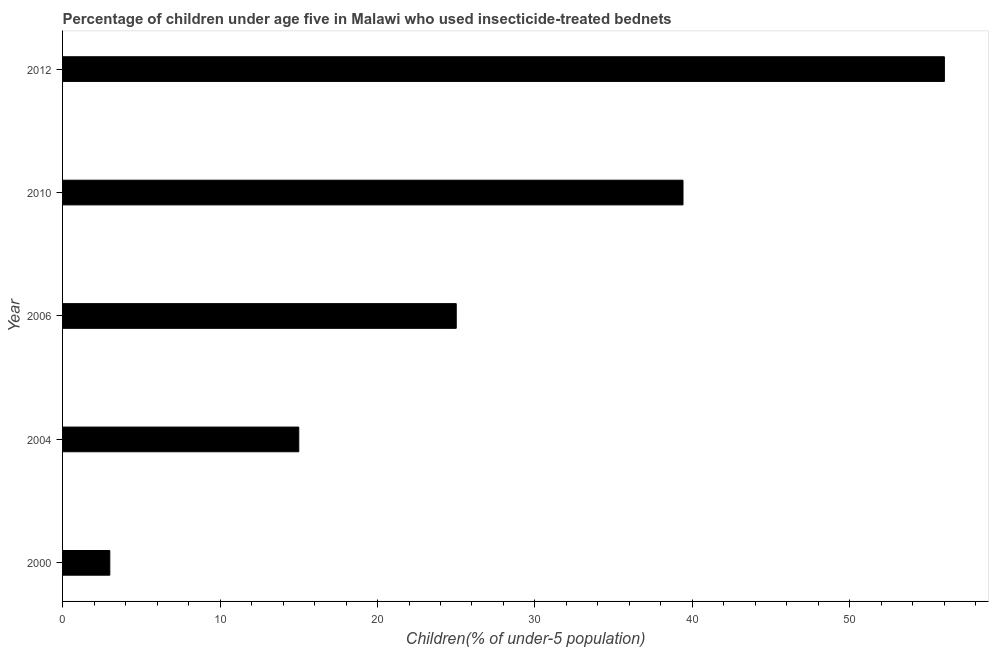Does the graph contain any zero values?
Ensure brevity in your answer.  No. Does the graph contain grids?
Offer a terse response. No. What is the title of the graph?
Make the answer very short. Percentage of children under age five in Malawi who used insecticide-treated bednets. What is the label or title of the X-axis?
Your answer should be very brief. Children(% of under-5 population). Across all years, what is the maximum percentage of children who use of insecticide-treated bed nets?
Give a very brief answer. 56. Across all years, what is the minimum percentage of children who use of insecticide-treated bed nets?
Make the answer very short. 3. In which year was the percentage of children who use of insecticide-treated bed nets maximum?
Your response must be concise. 2012. In which year was the percentage of children who use of insecticide-treated bed nets minimum?
Provide a short and direct response. 2000. What is the sum of the percentage of children who use of insecticide-treated bed nets?
Keep it short and to the point. 138.4. What is the difference between the percentage of children who use of insecticide-treated bed nets in 2006 and 2010?
Provide a short and direct response. -14.4. What is the average percentage of children who use of insecticide-treated bed nets per year?
Offer a terse response. 27.68. What is the median percentage of children who use of insecticide-treated bed nets?
Keep it short and to the point. 25. What is the ratio of the percentage of children who use of insecticide-treated bed nets in 2004 to that in 2012?
Offer a terse response. 0.27. Is the percentage of children who use of insecticide-treated bed nets in 2004 less than that in 2006?
Keep it short and to the point. Yes. Is the difference between the percentage of children who use of insecticide-treated bed nets in 2010 and 2012 greater than the difference between any two years?
Keep it short and to the point. No. In how many years, is the percentage of children who use of insecticide-treated bed nets greater than the average percentage of children who use of insecticide-treated bed nets taken over all years?
Your answer should be very brief. 2. How many years are there in the graph?
Provide a succinct answer. 5. What is the difference between two consecutive major ticks on the X-axis?
Your answer should be very brief. 10. Are the values on the major ticks of X-axis written in scientific E-notation?
Make the answer very short. No. What is the Children(% of under-5 population) in 2004?
Provide a succinct answer. 15. What is the Children(% of under-5 population) of 2006?
Your answer should be very brief. 25. What is the Children(% of under-5 population) of 2010?
Your answer should be very brief. 39.4. What is the difference between the Children(% of under-5 population) in 2000 and 2004?
Ensure brevity in your answer.  -12. What is the difference between the Children(% of under-5 population) in 2000 and 2010?
Offer a very short reply. -36.4. What is the difference between the Children(% of under-5 population) in 2000 and 2012?
Offer a terse response. -53. What is the difference between the Children(% of under-5 population) in 2004 and 2006?
Your answer should be compact. -10. What is the difference between the Children(% of under-5 population) in 2004 and 2010?
Give a very brief answer. -24.4. What is the difference between the Children(% of under-5 population) in 2004 and 2012?
Make the answer very short. -41. What is the difference between the Children(% of under-5 population) in 2006 and 2010?
Provide a short and direct response. -14.4. What is the difference between the Children(% of under-5 population) in 2006 and 2012?
Offer a terse response. -31. What is the difference between the Children(% of under-5 population) in 2010 and 2012?
Provide a short and direct response. -16.6. What is the ratio of the Children(% of under-5 population) in 2000 to that in 2006?
Offer a very short reply. 0.12. What is the ratio of the Children(% of under-5 population) in 2000 to that in 2010?
Ensure brevity in your answer.  0.08. What is the ratio of the Children(% of under-5 population) in 2000 to that in 2012?
Give a very brief answer. 0.05. What is the ratio of the Children(% of under-5 population) in 2004 to that in 2010?
Offer a terse response. 0.38. What is the ratio of the Children(% of under-5 population) in 2004 to that in 2012?
Your answer should be compact. 0.27. What is the ratio of the Children(% of under-5 population) in 2006 to that in 2010?
Provide a succinct answer. 0.64. What is the ratio of the Children(% of under-5 population) in 2006 to that in 2012?
Your answer should be very brief. 0.45. What is the ratio of the Children(% of under-5 population) in 2010 to that in 2012?
Keep it short and to the point. 0.7. 